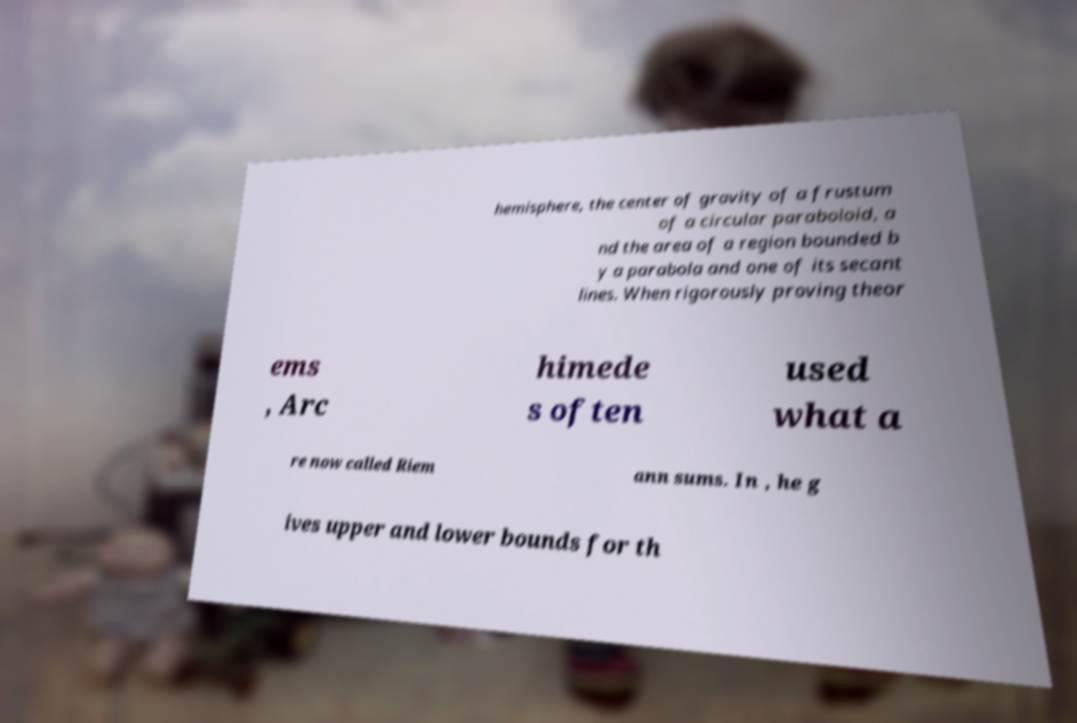For documentation purposes, I need the text within this image transcribed. Could you provide that? hemisphere, the center of gravity of a frustum of a circular paraboloid, a nd the area of a region bounded b y a parabola and one of its secant lines. When rigorously proving theor ems , Arc himede s often used what a re now called Riem ann sums. In , he g ives upper and lower bounds for th 